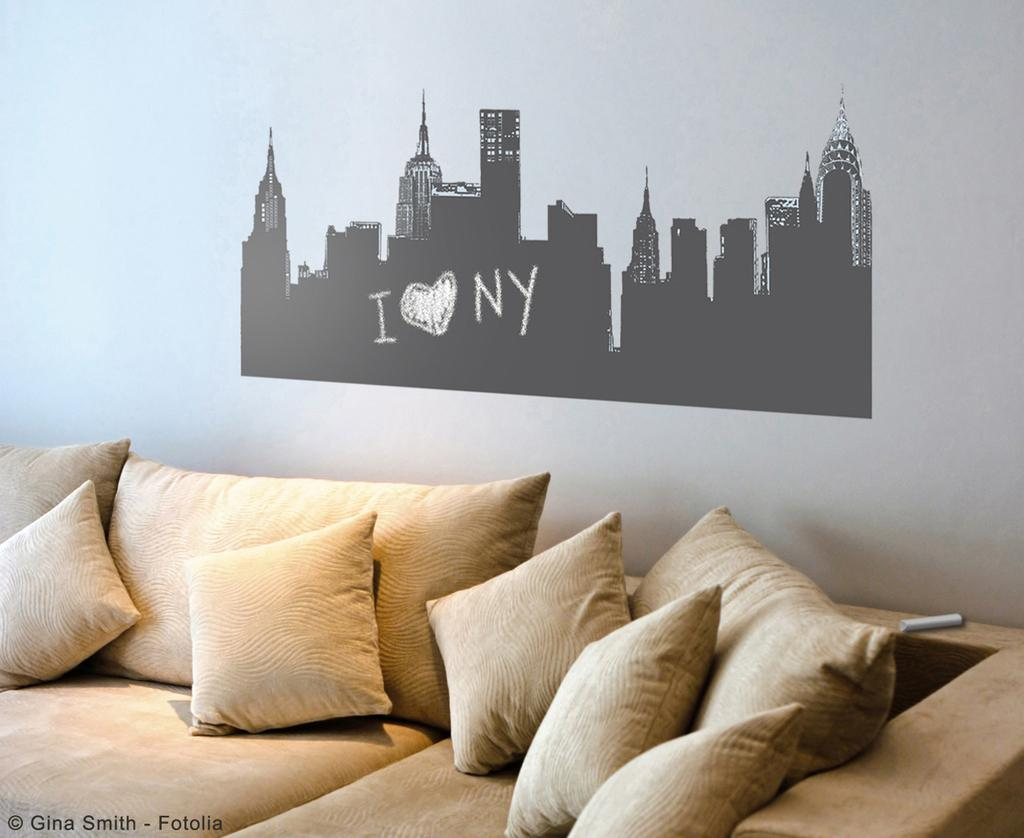What type of furniture is in the image? There is a couch in the image. What is placed on the couch? There are pillows and cushions on the couch. What can be seen on the wall in the image? There is art on the wall in the image. How many people are in the crowd gathered around the couch in the image? There is no crowd present in the image; it only shows a couch with pillows and cushions. 